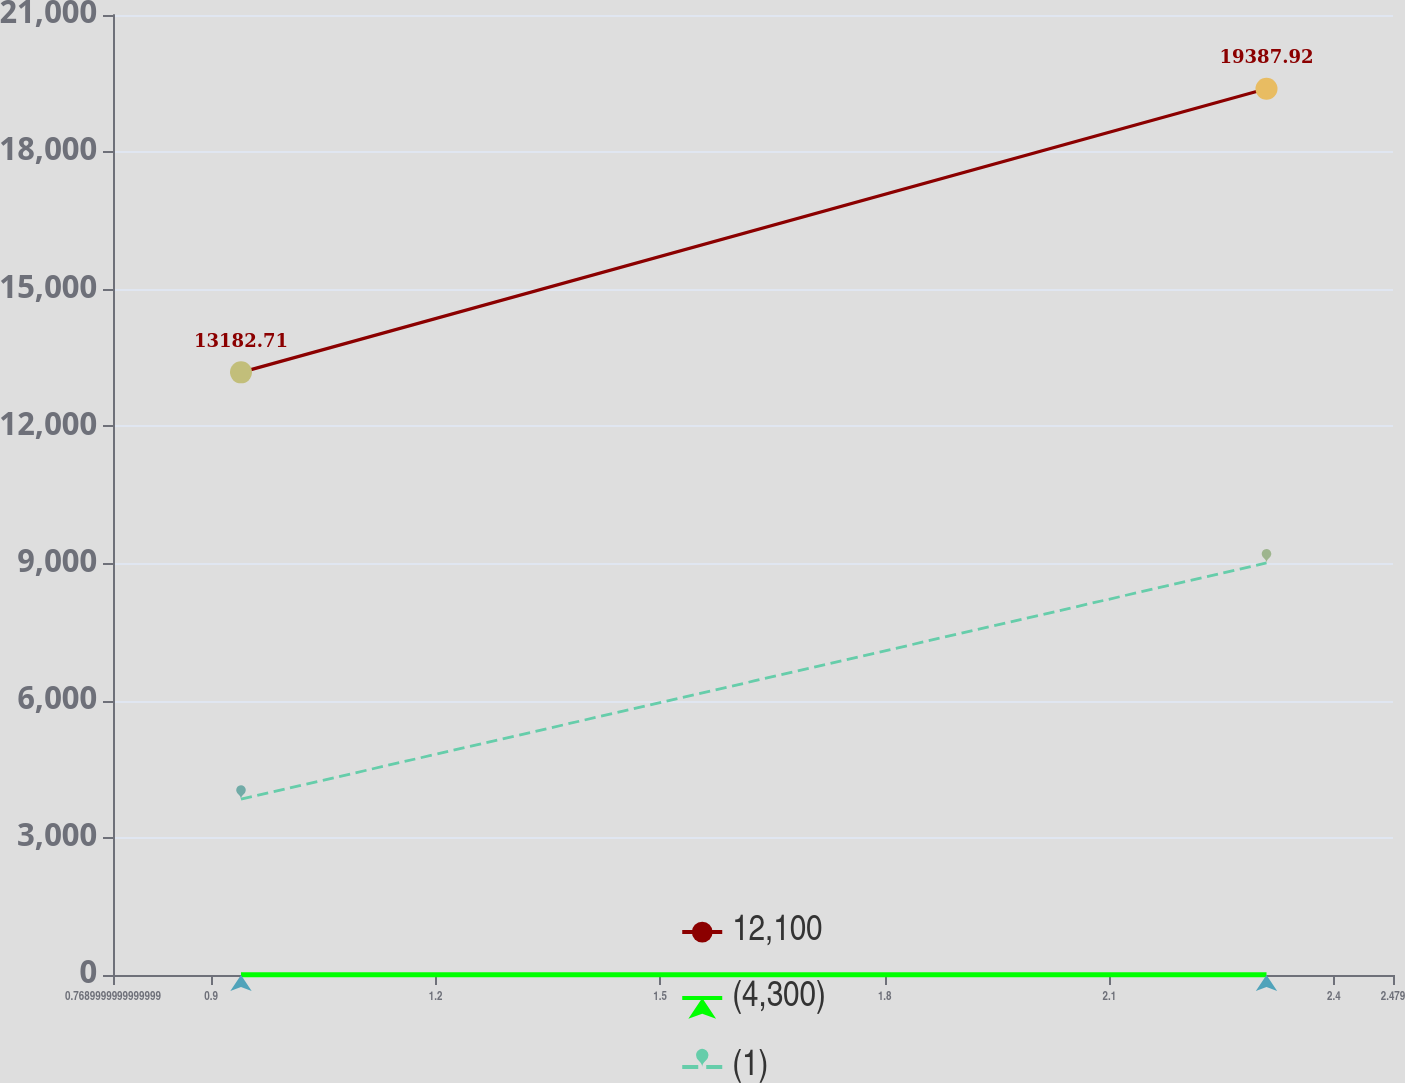Convert chart to OTSL. <chart><loc_0><loc_0><loc_500><loc_500><line_chart><ecel><fcel>12,100<fcel>(4,300)<fcel>(1)<nl><fcel>0.94<fcel>13182.7<fcel>0.84<fcel>3846.66<nl><fcel>2.31<fcel>19387.9<fcel>1.92<fcel>9014.18<nl><fcel>2.65<fcel>35629.4<fcel>2.75<fcel>15661.3<nl></chart> 